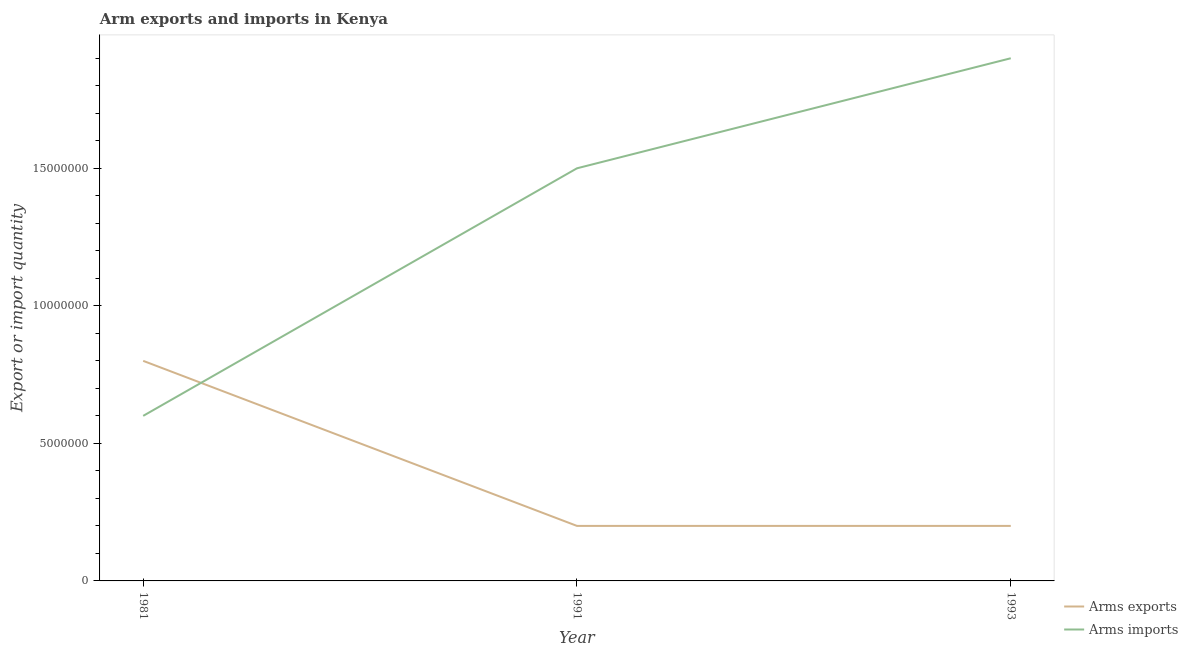Is the number of lines equal to the number of legend labels?
Your answer should be compact. Yes. What is the arms imports in 1991?
Offer a terse response. 1.50e+07. Across all years, what is the maximum arms imports?
Provide a short and direct response. 1.90e+07. Across all years, what is the minimum arms imports?
Make the answer very short. 6.00e+06. In which year was the arms imports maximum?
Offer a very short reply. 1993. In which year was the arms exports minimum?
Give a very brief answer. 1991. What is the total arms exports in the graph?
Keep it short and to the point. 1.20e+07. What is the difference between the arms exports in 1981 and that in 1991?
Offer a terse response. 6.00e+06. What is the difference between the arms exports in 1993 and the arms imports in 1981?
Offer a very short reply. -4.00e+06. In the year 1991, what is the difference between the arms exports and arms imports?
Keep it short and to the point. -1.30e+07. In how many years, is the arms imports greater than 17000000?
Your response must be concise. 1. What is the ratio of the arms exports in 1981 to that in 1991?
Offer a very short reply. 4. What is the difference between the highest and the lowest arms exports?
Keep it short and to the point. 6.00e+06. In how many years, is the arms exports greater than the average arms exports taken over all years?
Keep it short and to the point. 1. Is the sum of the arms exports in 1981 and 1993 greater than the maximum arms imports across all years?
Ensure brevity in your answer.  No. Is the arms exports strictly greater than the arms imports over the years?
Your answer should be compact. No. How many years are there in the graph?
Keep it short and to the point. 3. What is the difference between two consecutive major ticks on the Y-axis?
Ensure brevity in your answer.  5.00e+06. Are the values on the major ticks of Y-axis written in scientific E-notation?
Ensure brevity in your answer.  No. Does the graph contain any zero values?
Your answer should be very brief. No. Does the graph contain grids?
Your response must be concise. No. Where does the legend appear in the graph?
Make the answer very short. Bottom right. What is the title of the graph?
Your answer should be very brief. Arm exports and imports in Kenya. What is the label or title of the X-axis?
Make the answer very short. Year. What is the label or title of the Y-axis?
Make the answer very short. Export or import quantity. What is the Export or import quantity in Arms imports in 1981?
Provide a short and direct response. 6.00e+06. What is the Export or import quantity of Arms exports in 1991?
Provide a short and direct response. 2.00e+06. What is the Export or import quantity of Arms imports in 1991?
Give a very brief answer. 1.50e+07. What is the Export or import quantity in Arms imports in 1993?
Offer a terse response. 1.90e+07. Across all years, what is the maximum Export or import quantity in Arms exports?
Offer a terse response. 8.00e+06. Across all years, what is the maximum Export or import quantity of Arms imports?
Provide a short and direct response. 1.90e+07. Across all years, what is the minimum Export or import quantity in Arms exports?
Give a very brief answer. 2.00e+06. What is the total Export or import quantity of Arms exports in the graph?
Ensure brevity in your answer.  1.20e+07. What is the total Export or import quantity in Arms imports in the graph?
Your answer should be compact. 4.00e+07. What is the difference between the Export or import quantity in Arms imports in 1981 and that in 1991?
Ensure brevity in your answer.  -9.00e+06. What is the difference between the Export or import quantity of Arms exports in 1981 and that in 1993?
Ensure brevity in your answer.  6.00e+06. What is the difference between the Export or import quantity in Arms imports in 1981 and that in 1993?
Your answer should be compact. -1.30e+07. What is the difference between the Export or import quantity in Arms exports in 1991 and that in 1993?
Give a very brief answer. 0. What is the difference between the Export or import quantity of Arms imports in 1991 and that in 1993?
Your answer should be compact. -4.00e+06. What is the difference between the Export or import quantity in Arms exports in 1981 and the Export or import quantity in Arms imports in 1991?
Offer a very short reply. -7.00e+06. What is the difference between the Export or import quantity of Arms exports in 1981 and the Export or import quantity of Arms imports in 1993?
Keep it short and to the point. -1.10e+07. What is the difference between the Export or import quantity in Arms exports in 1991 and the Export or import quantity in Arms imports in 1993?
Offer a terse response. -1.70e+07. What is the average Export or import quantity in Arms exports per year?
Provide a succinct answer. 4.00e+06. What is the average Export or import quantity in Arms imports per year?
Your response must be concise. 1.33e+07. In the year 1981, what is the difference between the Export or import quantity of Arms exports and Export or import quantity of Arms imports?
Provide a succinct answer. 2.00e+06. In the year 1991, what is the difference between the Export or import quantity in Arms exports and Export or import quantity in Arms imports?
Offer a very short reply. -1.30e+07. In the year 1993, what is the difference between the Export or import quantity in Arms exports and Export or import quantity in Arms imports?
Your answer should be very brief. -1.70e+07. What is the ratio of the Export or import quantity of Arms exports in 1981 to that in 1991?
Offer a terse response. 4. What is the ratio of the Export or import quantity of Arms imports in 1981 to that in 1991?
Ensure brevity in your answer.  0.4. What is the ratio of the Export or import quantity in Arms imports in 1981 to that in 1993?
Your response must be concise. 0.32. What is the ratio of the Export or import quantity of Arms imports in 1991 to that in 1993?
Your answer should be compact. 0.79. What is the difference between the highest and the second highest Export or import quantity of Arms exports?
Your answer should be very brief. 6.00e+06. What is the difference between the highest and the lowest Export or import quantity in Arms imports?
Offer a very short reply. 1.30e+07. 